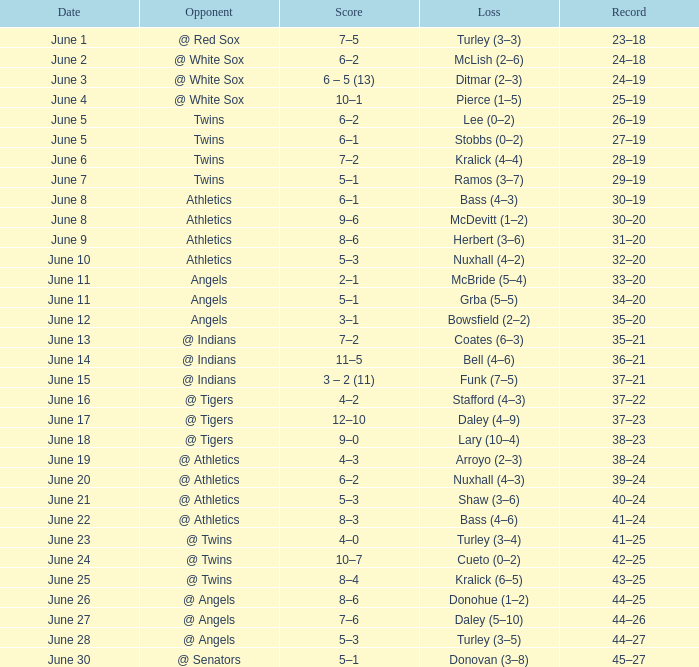What was the score from the game played on June 22? 8–3. 